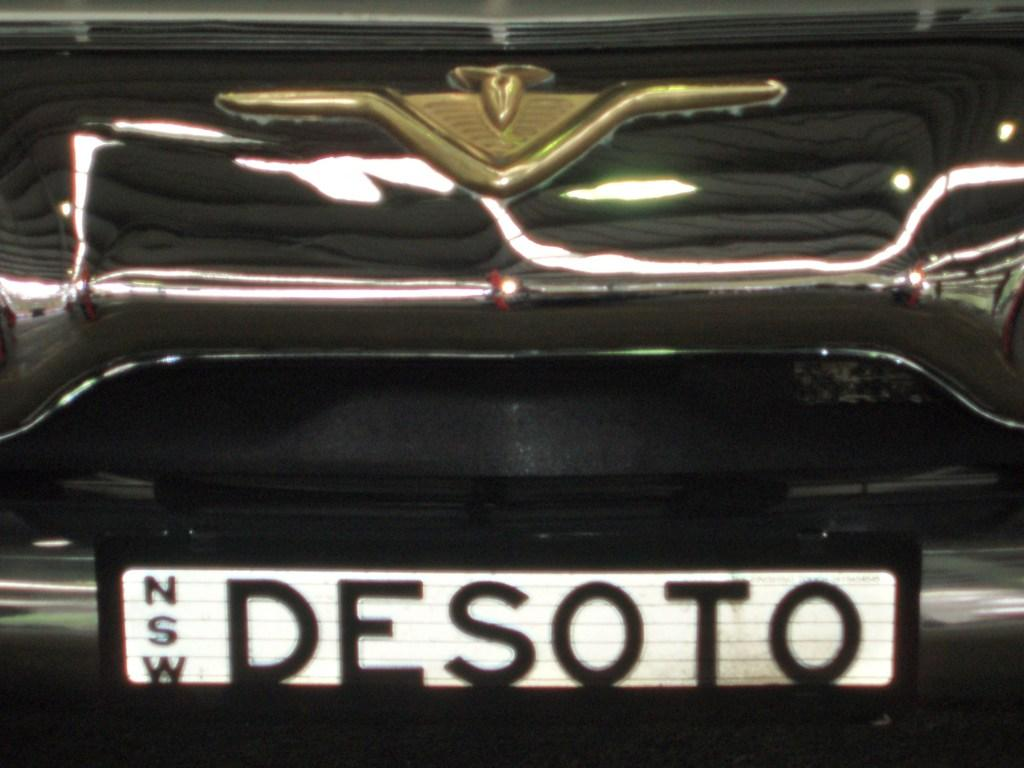<image>
Render a clear and concise summary of the photo. The back of a car with the license plate reading the word desoto in black text. 